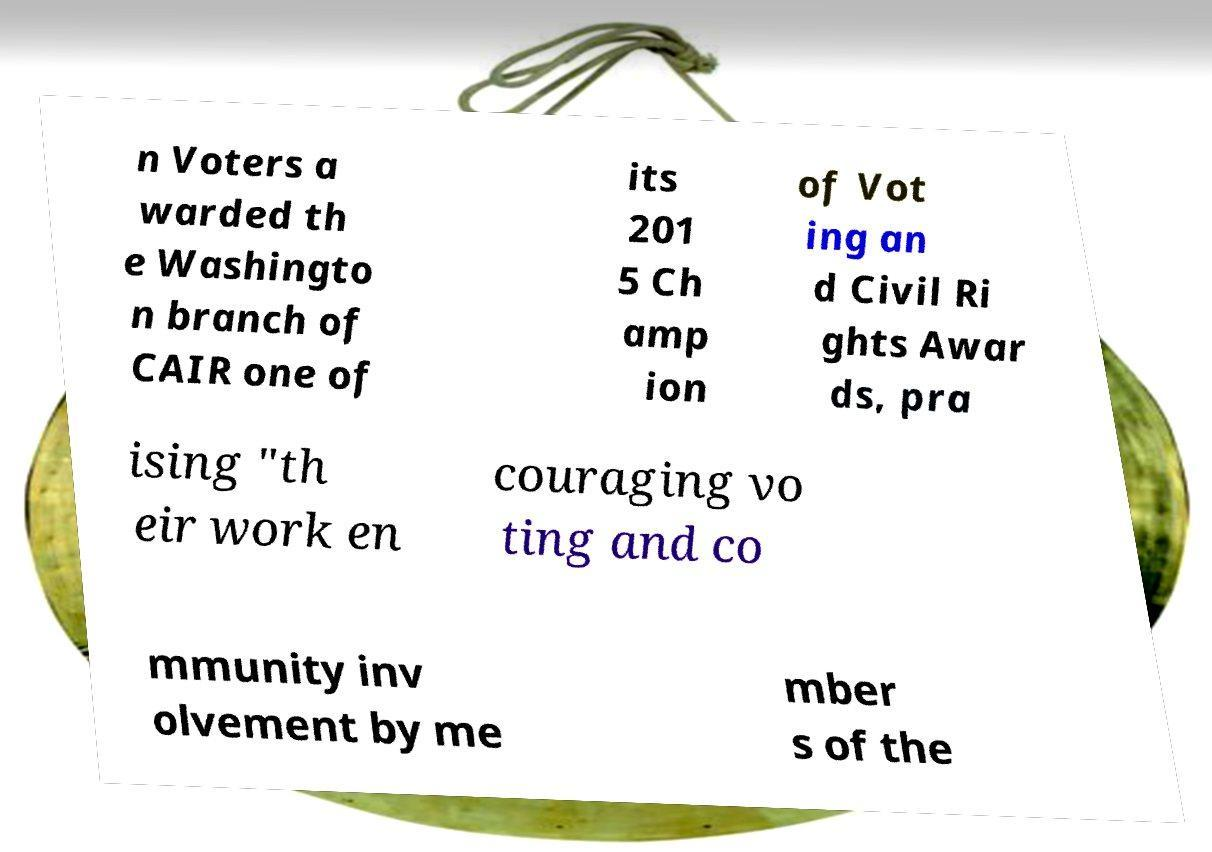Please read and relay the text visible in this image. What does it say? n Voters a warded th e Washingto n branch of CAIR one of its 201 5 Ch amp ion of Vot ing an d Civil Ri ghts Awar ds, pra ising "th eir work en couraging vo ting and co mmunity inv olvement by me mber s of the 